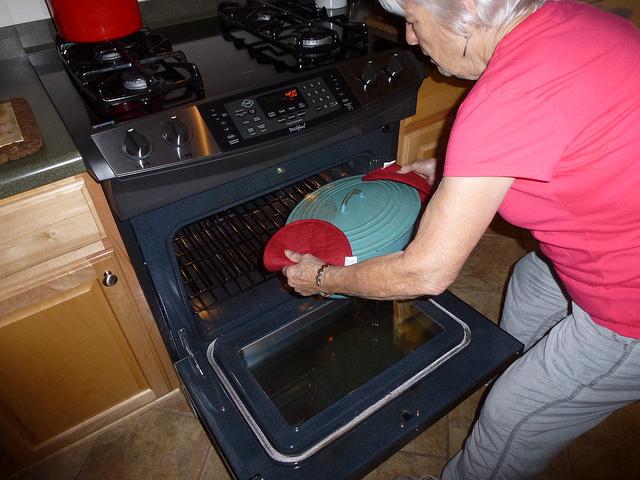What color are the pot holders?
Concise answer only. Red. Does the stove use gas or electric?
Give a very brief answer. Gas. What is the woman using to hold the pot?
Answer briefly. Pot holders. 